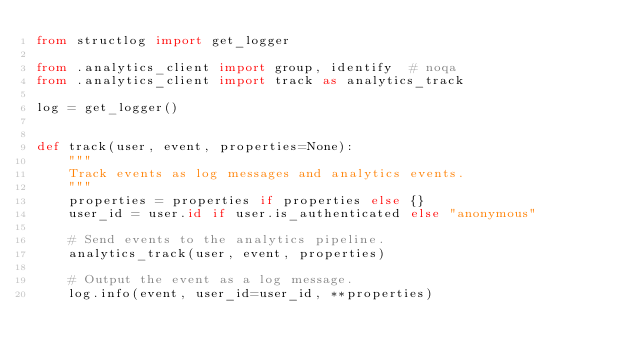<code> <loc_0><loc_0><loc_500><loc_500><_Python_>from structlog import get_logger

from .analytics_client import group, identify  # noqa
from .analytics_client import track as analytics_track

log = get_logger()


def track(user, event, properties=None):
    """
    Track events as log messages and analytics events.
    """
    properties = properties if properties else {}
    user_id = user.id if user.is_authenticated else "anonymous"

    # Send events to the analytics pipeline.
    analytics_track(user, event, properties)

    # Output the event as a log message.
    log.info(event, user_id=user_id, **properties)
</code> 